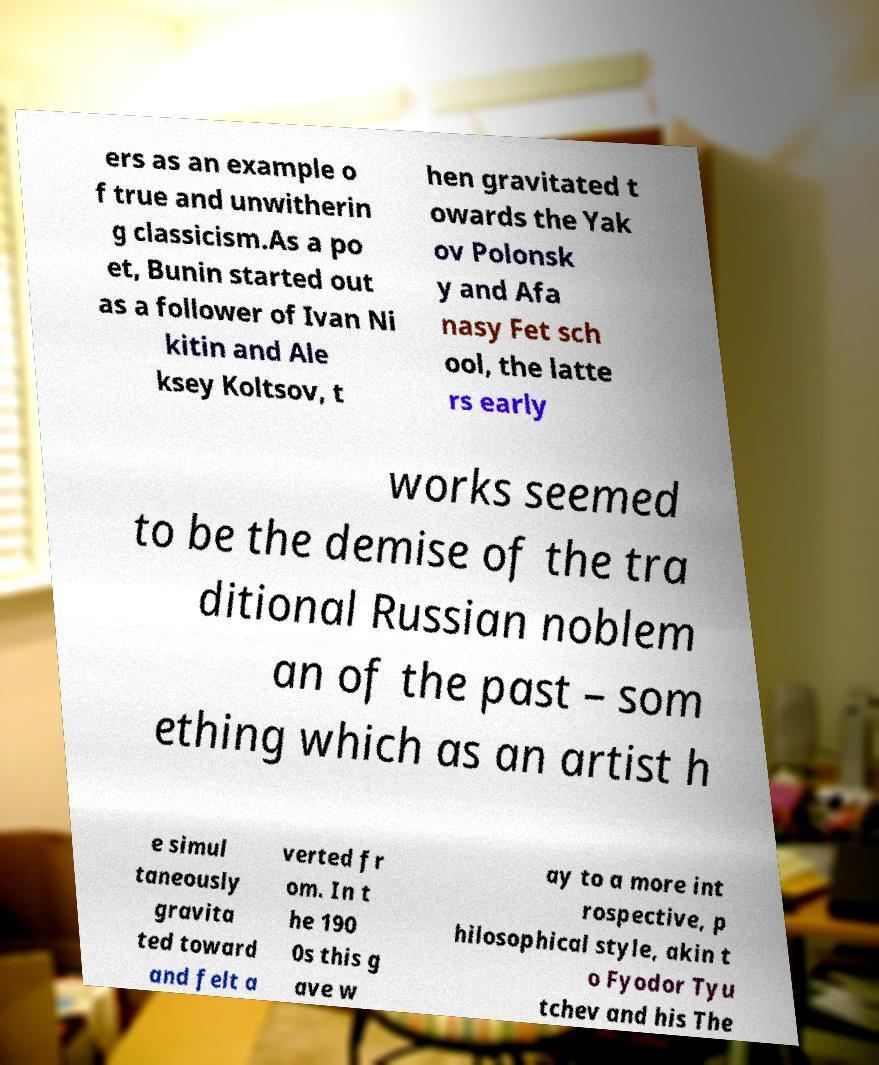Please read and relay the text visible in this image. What does it say? ers as an example o f true and unwitherin g classicism.As a po et, Bunin started out as a follower of Ivan Ni kitin and Ale ksey Koltsov, t hen gravitated t owards the Yak ov Polonsk y and Afa nasy Fet sch ool, the latte rs early works seemed to be the demise of the tra ditional Russian noblem an of the past – som ething which as an artist h e simul taneously gravita ted toward and felt a verted fr om. In t he 190 0s this g ave w ay to a more int rospective, p hilosophical style, akin t o Fyodor Tyu tchev and his The 